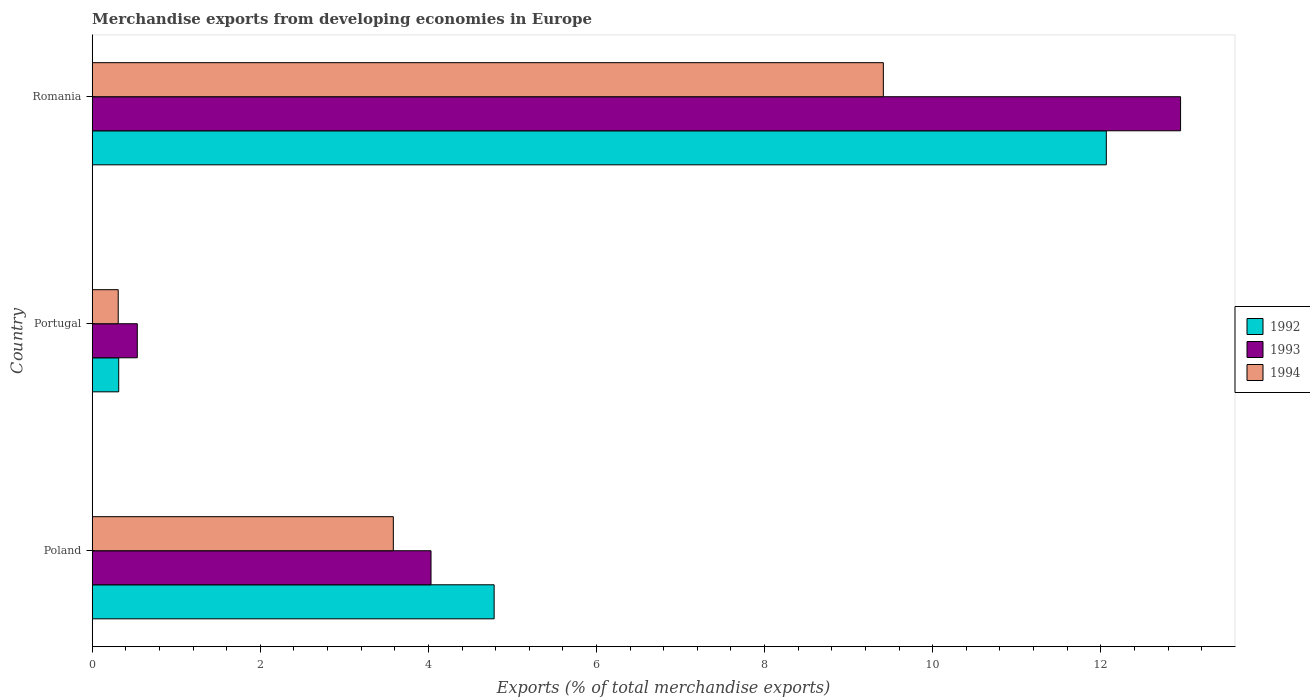Are the number of bars on each tick of the Y-axis equal?
Keep it short and to the point. Yes. How many bars are there on the 3rd tick from the bottom?
Make the answer very short. 3. What is the label of the 1st group of bars from the top?
Make the answer very short. Romania. What is the percentage of total merchandise exports in 1993 in Poland?
Offer a terse response. 4.03. Across all countries, what is the maximum percentage of total merchandise exports in 1994?
Ensure brevity in your answer.  9.41. Across all countries, what is the minimum percentage of total merchandise exports in 1992?
Give a very brief answer. 0.32. In which country was the percentage of total merchandise exports in 1994 maximum?
Give a very brief answer. Romania. What is the total percentage of total merchandise exports in 1992 in the graph?
Offer a terse response. 17.16. What is the difference between the percentage of total merchandise exports in 1993 in Portugal and that in Romania?
Provide a succinct answer. -12.41. What is the difference between the percentage of total merchandise exports in 1992 in Poland and the percentage of total merchandise exports in 1994 in Portugal?
Provide a succinct answer. 4.47. What is the average percentage of total merchandise exports in 1993 per country?
Provide a short and direct response. 5.84. What is the difference between the percentage of total merchandise exports in 1993 and percentage of total merchandise exports in 1992 in Portugal?
Make the answer very short. 0.22. What is the ratio of the percentage of total merchandise exports in 1994 in Poland to that in Portugal?
Make the answer very short. 11.59. Is the percentage of total merchandise exports in 1994 in Poland less than that in Romania?
Provide a short and direct response. Yes. Is the difference between the percentage of total merchandise exports in 1993 in Portugal and Romania greater than the difference between the percentage of total merchandise exports in 1992 in Portugal and Romania?
Keep it short and to the point. No. What is the difference between the highest and the second highest percentage of total merchandise exports in 1993?
Offer a very short reply. 8.92. What is the difference between the highest and the lowest percentage of total merchandise exports in 1994?
Your answer should be very brief. 9.1. In how many countries, is the percentage of total merchandise exports in 1994 greater than the average percentage of total merchandise exports in 1994 taken over all countries?
Ensure brevity in your answer.  1. Is the sum of the percentage of total merchandise exports in 1994 in Poland and Portugal greater than the maximum percentage of total merchandise exports in 1992 across all countries?
Provide a short and direct response. No. What does the 3rd bar from the top in Romania represents?
Give a very brief answer. 1992. What does the 1st bar from the bottom in Poland represents?
Offer a very short reply. 1992. How many bars are there?
Offer a very short reply. 9. Are all the bars in the graph horizontal?
Give a very brief answer. Yes. What is the difference between two consecutive major ticks on the X-axis?
Your response must be concise. 2. Are the values on the major ticks of X-axis written in scientific E-notation?
Make the answer very short. No. Does the graph contain grids?
Offer a very short reply. No. How many legend labels are there?
Offer a very short reply. 3. What is the title of the graph?
Provide a succinct answer. Merchandise exports from developing economies in Europe. What is the label or title of the X-axis?
Your response must be concise. Exports (% of total merchandise exports). What is the label or title of the Y-axis?
Offer a very short reply. Country. What is the Exports (% of total merchandise exports) of 1992 in Poland?
Make the answer very short. 4.78. What is the Exports (% of total merchandise exports) of 1993 in Poland?
Your answer should be compact. 4.03. What is the Exports (% of total merchandise exports) in 1994 in Poland?
Your response must be concise. 3.58. What is the Exports (% of total merchandise exports) of 1992 in Portugal?
Your answer should be compact. 0.32. What is the Exports (% of total merchandise exports) in 1993 in Portugal?
Provide a succinct answer. 0.54. What is the Exports (% of total merchandise exports) in 1994 in Portugal?
Make the answer very short. 0.31. What is the Exports (% of total merchandise exports) in 1992 in Romania?
Make the answer very short. 12.07. What is the Exports (% of total merchandise exports) of 1993 in Romania?
Make the answer very short. 12.95. What is the Exports (% of total merchandise exports) in 1994 in Romania?
Your answer should be very brief. 9.41. Across all countries, what is the maximum Exports (% of total merchandise exports) of 1992?
Give a very brief answer. 12.07. Across all countries, what is the maximum Exports (% of total merchandise exports) in 1993?
Provide a short and direct response. 12.95. Across all countries, what is the maximum Exports (% of total merchandise exports) in 1994?
Your answer should be compact. 9.41. Across all countries, what is the minimum Exports (% of total merchandise exports) in 1992?
Provide a succinct answer. 0.32. Across all countries, what is the minimum Exports (% of total merchandise exports) in 1993?
Ensure brevity in your answer.  0.54. Across all countries, what is the minimum Exports (% of total merchandise exports) in 1994?
Keep it short and to the point. 0.31. What is the total Exports (% of total merchandise exports) in 1992 in the graph?
Offer a terse response. 17.16. What is the total Exports (% of total merchandise exports) of 1993 in the graph?
Make the answer very short. 17.52. What is the total Exports (% of total merchandise exports) in 1994 in the graph?
Give a very brief answer. 13.3. What is the difference between the Exports (% of total merchandise exports) of 1992 in Poland and that in Portugal?
Make the answer very short. 4.47. What is the difference between the Exports (% of total merchandise exports) in 1993 in Poland and that in Portugal?
Your answer should be very brief. 3.49. What is the difference between the Exports (% of total merchandise exports) in 1994 in Poland and that in Portugal?
Ensure brevity in your answer.  3.27. What is the difference between the Exports (% of total merchandise exports) of 1992 in Poland and that in Romania?
Your response must be concise. -7.28. What is the difference between the Exports (% of total merchandise exports) in 1993 in Poland and that in Romania?
Your answer should be very brief. -8.92. What is the difference between the Exports (% of total merchandise exports) in 1994 in Poland and that in Romania?
Keep it short and to the point. -5.83. What is the difference between the Exports (% of total merchandise exports) in 1992 in Portugal and that in Romania?
Keep it short and to the point. -11.75. What is the difference between the Exports (% of total merchandise exports) of 1993 in Portugal and that in Romania?
Offer a very short reply. -12.41. What is the difference between the Exports (% of total merchandise exports) in 1994 in Portugal and that in Romania?
Provide a short and direct response. -9.1. What is the difference between the Exports (% of total merchandise exports) in 1992 in Poland and the Exports (% of total merchandise exports) in 1993 in Portugal?
Your answer should be compact. 4.25. What is the difference between the Exports (% of total merchandise exports) of 1992 in Poland and the Exports (% of total merchandise exports) of 1994 in Portugal?
Your response must be concise. 4.47. What is the difference between the Exports (% of total merchandise exports) in 1993 in Poland and the Exports (% of total merchandise exports) in 1994 in Portugal?
Provide a short and direct response. 3.72. What is the difference between the Exports (% of total merchandise exports) in 1992 in Poland and the Exports (% of total merchandise exports) in 1993 in Romania?
Ensure brevity in your answer.  -8.17. What is the difference between the Exports (% of total merchandise exports) of 1992 in Poland and the Exports (% of total merchandise exports) of 1994 in Romania?
Provide a short and direct response. -4.63. What is the difference between the Exports (% of total merchandise exports) of 1993 in Poland and the Exports (% of total merchandise exports) of 1994 in Romania?
Offer a terse response. -5.38. What is the difference between the Exports (% of total merchandise exports) in 1992 in Portugal and the Exports (% of total merchandise exports) in 1993 in Romania?
Your response must be concise. -12.63. What is the difference between the Exports (% of total merchandise exports) in 1992 in Portugal and the Exports (% of total merchandise exports) in 1994 in Romania?
Provide a succinct answer. -9.1. What is the difference between the Exports (% of total merchandise exports) in 1993 in Portugal and the Exports (% of total merchandise exports) in 1994 in Romania?
Your response must be concise. -8.88. What is the average Exports (% of total merchandise exports) of 1992 per country?
Offer a very short reply. 5.72. What is the average Exports (% of total merchandise exports) in 1993 per country?
Your answer should be very brief. 5.84. What is the average Exports (% of total merchandise exports) in 1994 per country?
Keep it short and to the point. 4.43. What is the difference between the Exports (% of total merchandise exports) in 1992 and Exports (% of total merchandise exports) in 1993 in Poland?
Provide a succinct answer. 0.75. What is the difference between the Exports (% of total merchandise exports) in 1992 and Exports (% of total merchandise exports) in 1994 in Poland?
Give a very brief answer. 1.2. What is the difference between the Exports (% of total merchandise exports) of 1993 and Exports (% of total merchandise exports) of 1994 in Poland?
Ensure brevity in your answer.  0.45. What is the difference between the Exports (% of total merchandise exports) in 1992 and Exports (% of total merchandise exports) in 1993 in Portugal?
Offer a terse response. -0.22. What is the difference between the Exports (% of total merchandise exports) in 1992 and Exports (% of total merchandise exports) in 1994 in Portugal?
Your answer should be very brief. 0.01. What is the difference between the Exports (% of total merchandise exports) in 1993 and Exports (% of total merchandise exports) in 1994 in Portugal?
Ensure brevity in your answer.  0.23. What is the difference between the Exports (% of total merchandise exports) of 1992 and Exports (% of total merchandise exports) of 1993 in Romania?
Your answer should be compact. -0.88. What is the difference between the Exports (% of total merchandise exports) of 1992 and Exports (% of total merchandise exports) of 1994 in Romania?
Your response must be concise. 2.65. What is the difference between the Exports (% of total merchandise exports) of 1993 and Exports (% of total merchandise exports) of 1994 in Romania?
Offer a very short reply. 3.54. What is the ratio of the Exports (% of total merchandise exports) in 1992 in Poland to that in Portugal?
Your answer should be very brief. 15.18. What is the ratio of the Exports (% of total merchandise exports) of 1993 in Poland to that in Portugal?
Make the answer very short. 7.52. What is the ratio of the Exports (% of total merchandise exports) in 1994 in Poland to that in Portugal?
Your answer should be compact. 11.59. What is the ratio of the Exports (% of total merchandise exports) in 1992 in Poland to that in Romania?
Your answer should be very brief. 0.4. What is the ratio of the Exports (% of total merchandise exports) of 1993 in Poland to that in Romania?
Provide a short and direct response. 0.31. What is the ratio of the Exports (% of total merchandise exports) of 1994 in Poland to that in Romania?
Give a very brief answer. 0.38. What is the ratio of the Exports (% of total merchandise exports) in 1992 in Portugal to that in Romania?
Make the answer very short. 0.03. What is the ratio of the Exports (% of total merchandise exports) in 1993 in Portugal to that in Romania?
Your answer should be compact. 0.04. What is the ratio of the Exports (% of total merchandise exports) in 1994 in Portugal to that in Romania?
Keep it short and to the point. 0.03. What is the difference between the highest and the second highest Exports (% of total merchandise exports) in 1992?
Offer a terse response. 7.28. What is the difference between the highest and the second highest Exports (% of total merchandise exports) in 1993?
Ensure brevity in your answer.  8.92. What is the difference between the highest and the second highest Exports (% of total merchandise exports) in 1994?
Give a very brief answer. 5.83. What is the difference between the highest and the lowest Exports (% of total merchandise exports) in 1992?
Keep it short and to the point. 11.75. What is the difference between the highest and the lowest Exports (% of total merchandise exports) of 1993?
Your answer should be compact. 12.41. What is the difference between the highest and the lowest Exports (% of total merchandise exports) in 1994?
Provide a succinct answer. 9.1. 